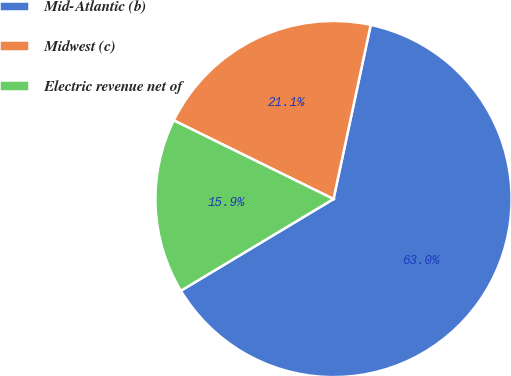Convert chart to OTSL. <chart><loc_0><loc_0><loc_500><loc_500><pie_chart><fcel>Mid-Atlantic (b)<fcel>Midwest (c)<fcel>Electric revenue net of<nl><fcel>63.04%<fcel>21.07%<fcel>15.89%<nl></chart> 